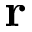<formula> <loc_0><loc_0><loc_500><loc_500>r</formula> 